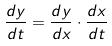Convert formula to latex. <formula><loc_0><loc_0><loc_500><loc_500>\frac { d y } { d t } = \frac { d y } { d x } \cdot \frac { d x } { d t }</formula> 